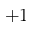<formula> <loc_0><loc_0><loc_500><loc_500>+ 1</formula> 